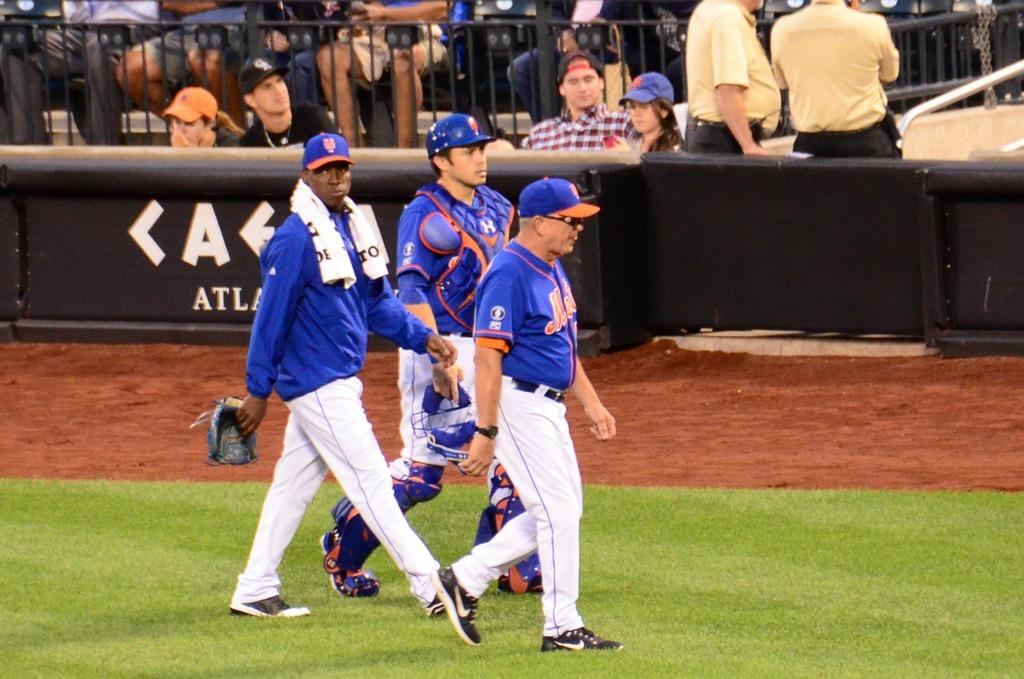<image>
Offer a succinct explanation of the picture presented. Three players for the Mets are walking on the grass. 